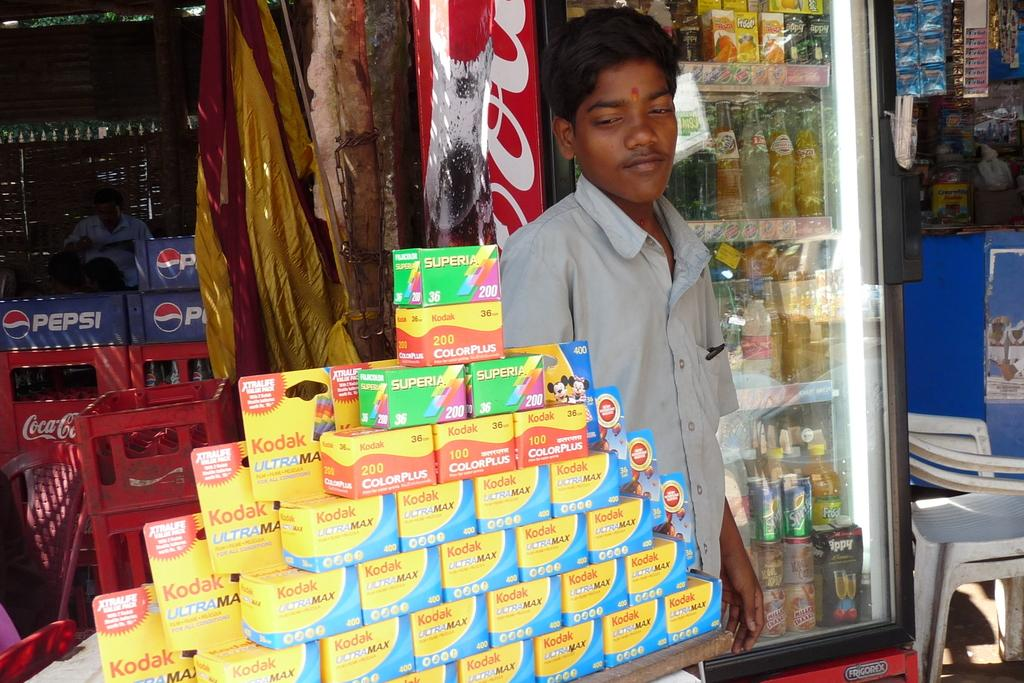<image>
Present a compact description of the photo's key features. A young man standing next to a table with stacked Kodak film boxes on top. 